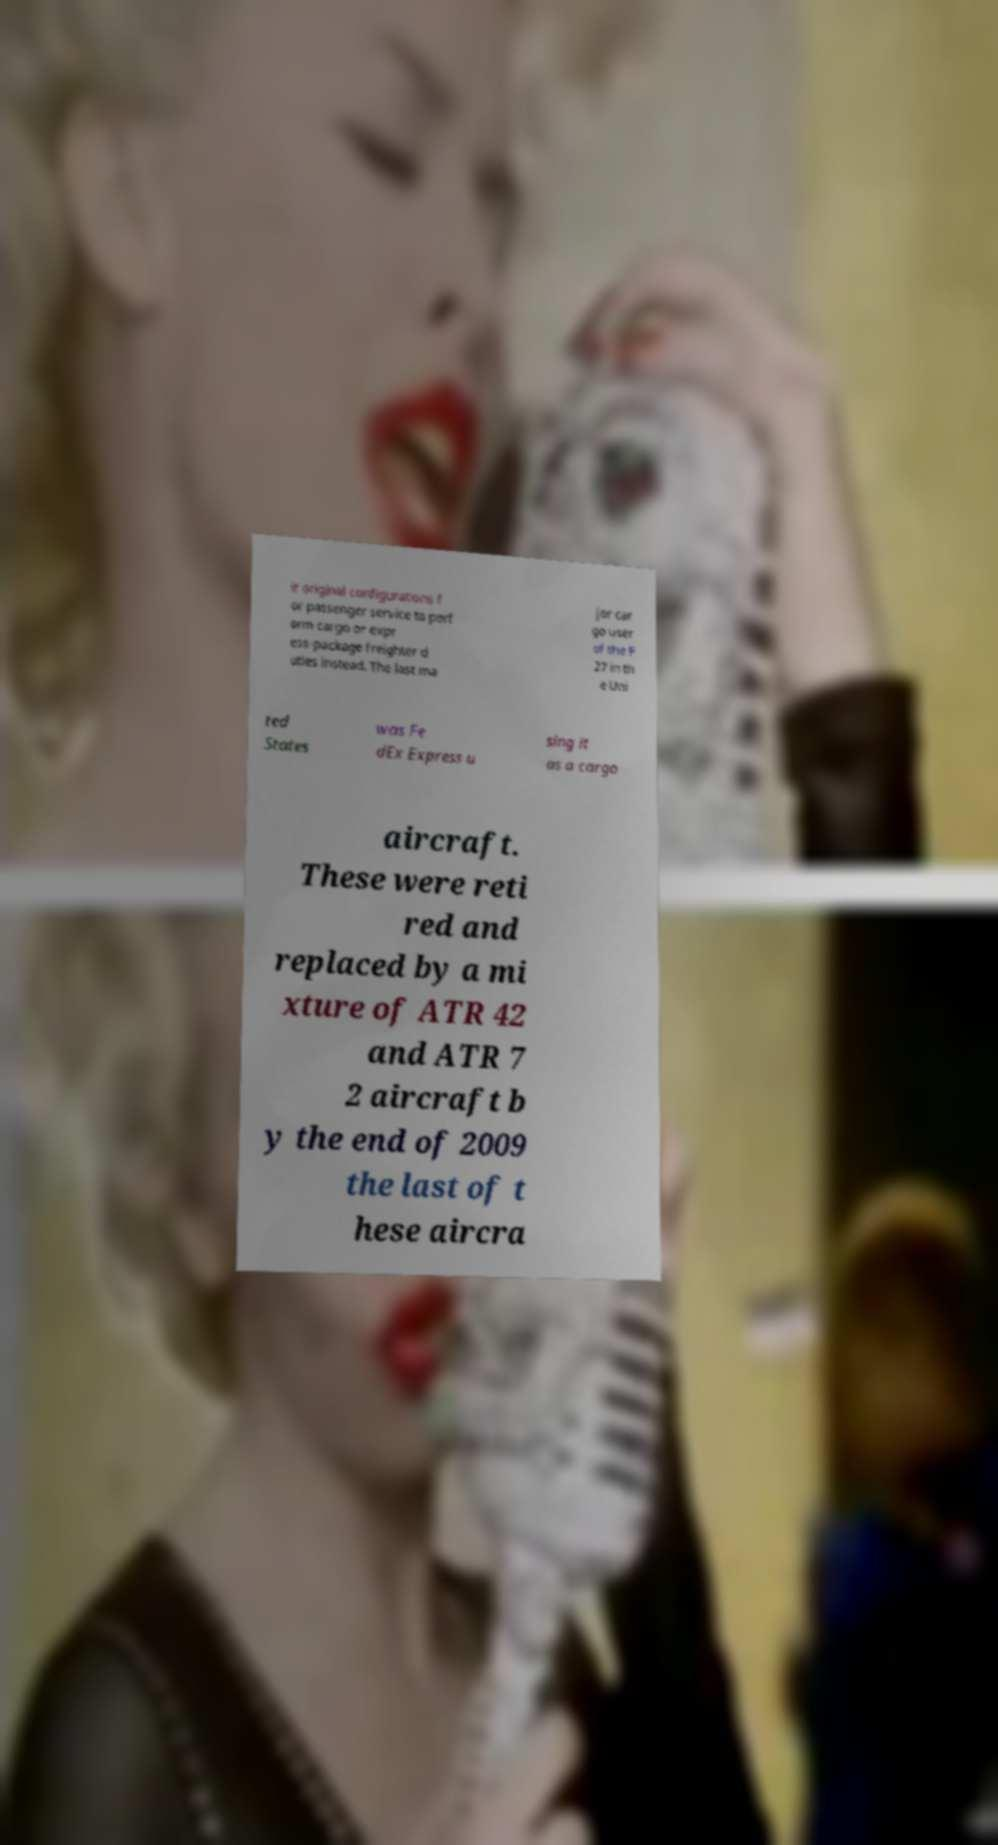Can you accurately transcribe the text from the provided image for me? ir original configurations f or passenger service to perf orm cargo or expr ess-package freighter d uties instead. The last ma jor car go user of the F 27 in th e Uni ted States was Fe dEx Express u sing it as a cargo aircraft. These were reti red and replaced by a mi xture of ATR 42 and ATR 7 2 aircraft b y the end of 2009 the last of t hese aircra 